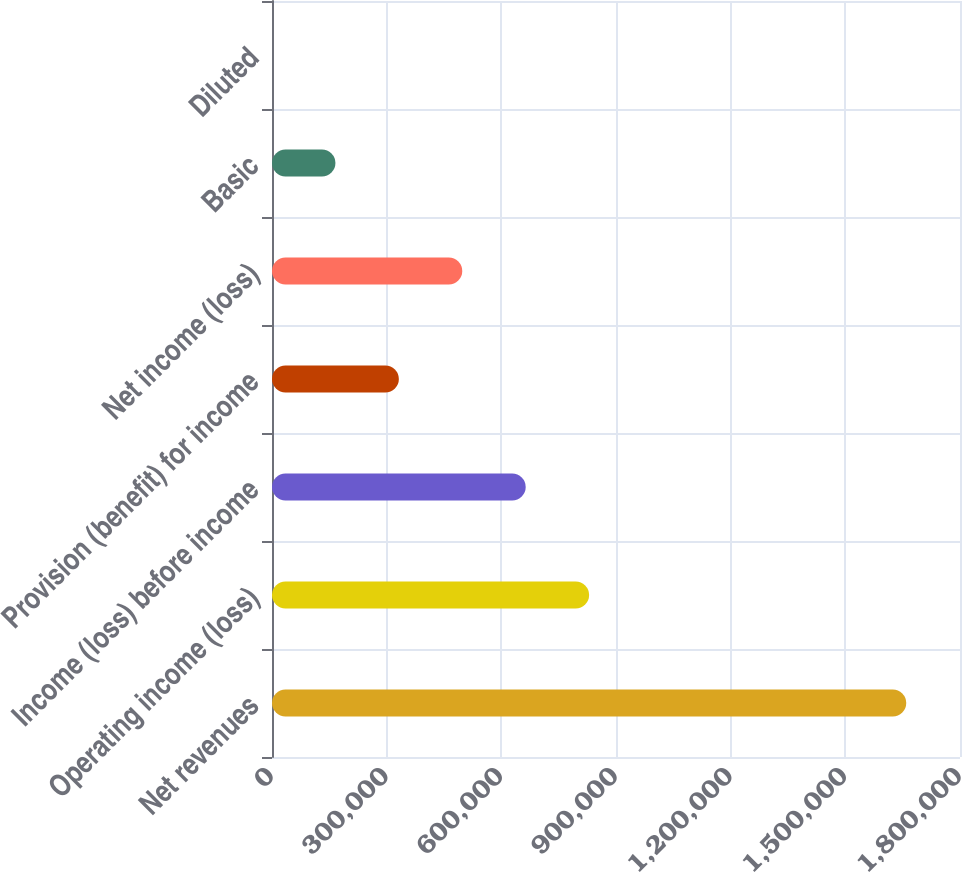<chart> <loc_0><loc_0><loc_500><loc_500><bar_chart><fcel>Net revenues<fcel>Operating income (loss)<fcel>Income (loss) before income<fcel>Provision (benefit) for income<fcel>Net income (loss)<fcel>Basic<fcel>Diluted<nl><fcel>1.65936e+06<fcel>829679<fcel>663743<fcel>331872<fcel>497807<fcel>165936<fcel>0.1<nl></chart> 